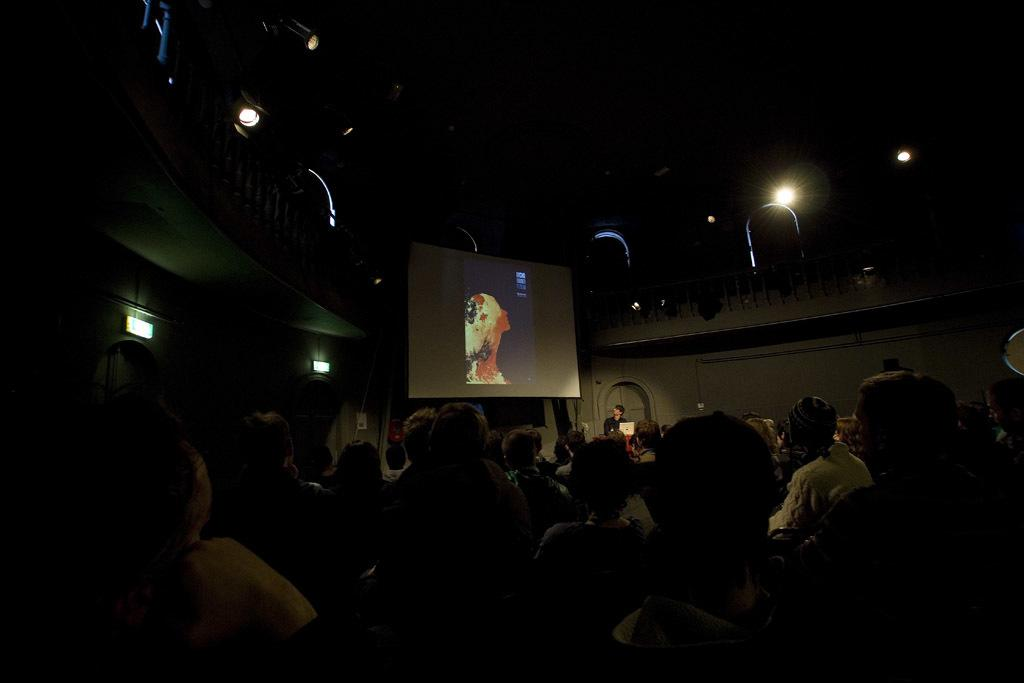What is the main activity of the people in the image? There is a group of people sitting in the image. What can be seen in the background of the image? There is a screen and lights visible in the background of the image. What error can be seen on the screen in the image? There is no error visible on the screen in the image; it is not mentioned in the provided facts. 